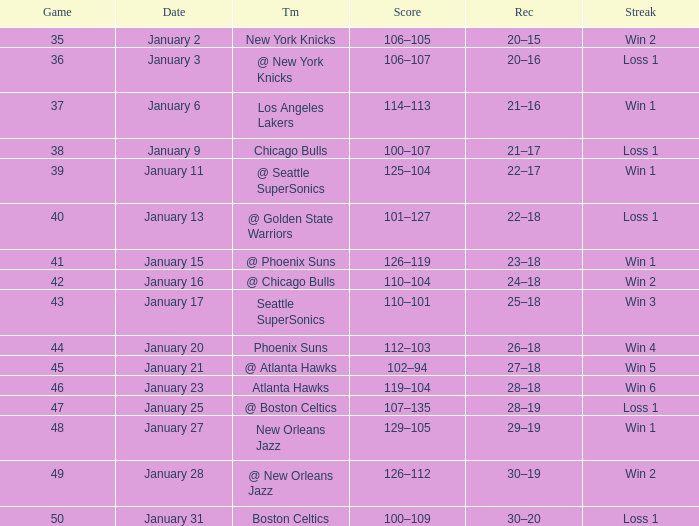What is the Team in Game 38? Chicago Bulls. 